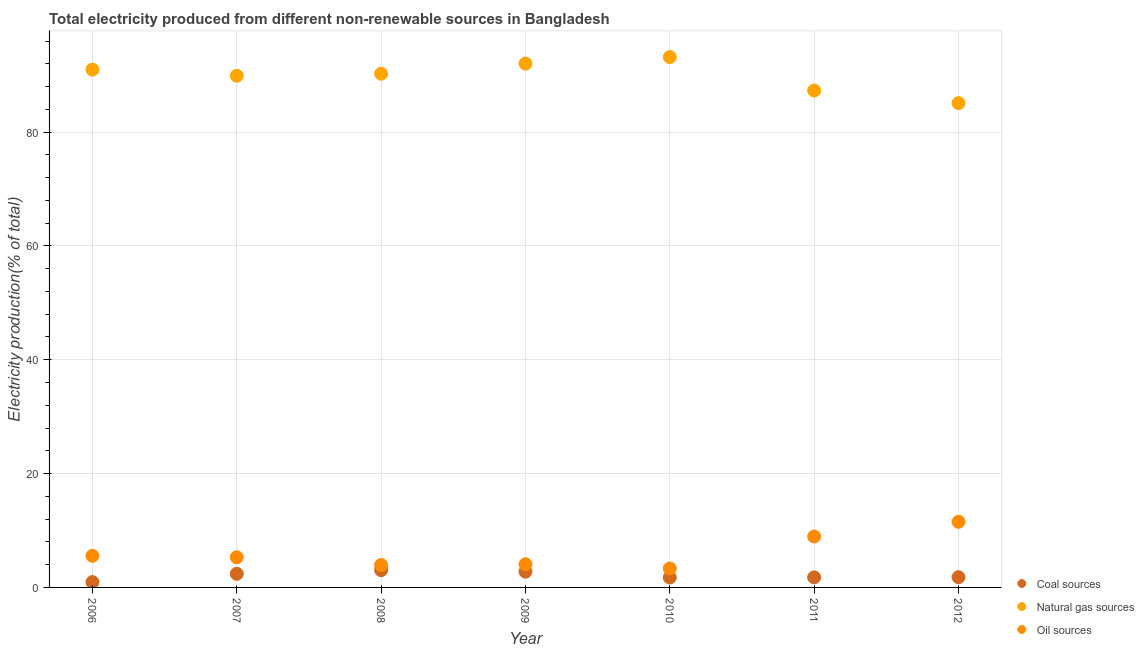What is the percentage of electricity produced by coal in 2007?
Give a very brief answer. 2.39. Across all years, what is the maximum percentage of electricity produced by natural gas?
Keep it short and to the point. 93.18. Across all years, what is the minimum percentage of electricity produced by natural gas?
Your answer should be compact. 85.09. What is the total percentage of electricity produced by oil sources in the graph?
Keep it short and to the point. 42.69. What is the difference between the percentage of electricity produced by natural gas in 2006 and that in 2011?
Your answer should be compact. 3.67. What is the difference between the percentage of electricity produced by natural gas in 2008 and the percentage of electricity produced by coal in 2009?
Offer a very short reply. 87.49. What is the average percentage of electricity produced by natural gas per year?
Your answer should be compact. 89.82. In the year 2011, what is the difference between the percentage of electricity produced by oil sources and percentage of electricity produced by natural gas?
Offer a very short reply. -78.35. In how many years, is the percentage of electricity produced by natural gas greater than 32 %?
Keep it short and to the point. 7. What is the ratio of the percentage of electricity produced by coal in 2006 to that in 2008?
Your answer should be compact. 0.31. Is the percentage of electricity produced by coal in 2010 less than that in 2012?
Give a very brief answer. Yes. What is the difference between the highest and the second highest percentage of electricity produced by oil sources?
Provide a succinct answer. 2.57. What is the difference between the highest and the lowest percentage of electricity produced by oil sources?
Provide a succinct answer. 8.19. In how many years, is the percentage of electricity produced by oil sources greater than the average percentage of electricity produced by oil sources taken over all years?
Keep it short and to the point. 2. How many dotlines are there?
Your answer should be compact. 3. What is the difference between two consecutive major ticks on the Y-axis?
Your response must be concise. 20. Does the graph contain grids?
Give a very brief answer. Yes. Where does the legend appear in the graph?
Make the answer very short. Bottom right. How many legend labels are there?
Your answer should be compact. 3. What is the title of the graph?
Offer a very short reply. Total electricity produced from different non-renewable sources in Bangladesh. Does "Spain" appear as one of the legend labels in the graph?
Provide a succinct answer. No. What is the label or title of the X-axis?
Provide a succinct answer. Year. What is the Electricity production(% of total) of Coal sources in 2006?
Provide a succinct answer. 0.93. What is the Electricity production(% of total) of Natural gas sources in 2006?
Provide a short and direct response. 90.98. What is the Electricity production(% of total) in Oil sources in 2006?
Your answer should be very brief. 5.55. What is the Electricity production(% of total) of Coal sources in 2007?
Your answer should be compact. 2.39. What is the Electricity production(% of total) of Natural gas sources in 2007?
Provide a succinct answer. 89.9. What is the Electricity production(% of total) of Oil sources in 2007?
Provide a succinct answer. 5.3. What is the Electricity production(% of total) in Coal sources in 2008?
Your answer should be very brief. 3.02. What is the Electricity production(% of total) of Natural gas sources in 2008?
Your answer should be compact. 90.26. What is the Electricity production(% of total) of Oil sources in 2008?
Your answer should be compact. 3.95. What is the Electricity production(% of total) of Coal sources in 2009?
Your answer should be compact. 2.77. What is the Electricity production(% of total) in Natural gas sources in 2009?
Offer a very short reply. 92.03. What is the Electricity production(% of total) in Oil sources in 2009?
Keep it short and to the point. 4.08. What is the Electricity production(% of total) in Coal sources in 2010?
Your answer should be very brief. 1.74. What is the Electricity production(% of total) of Natural gas sources in 2010?
Your answer should be compact. 93.18. What is the Electricity production(% of total) of Oil sources in 2010?
Provide a short and direct response. 3.33. What is the Electricity production(% of total) in Coal sources in 2011?
Offer a terse response. 1.77. What is the Electricity production(% of total) of Natural gas sources in 2011?
Your answer should be very brief. 87.31. What is the Electricity production(% of total) of Oil sources in 2011?
Make the answer very short. 8.95. What is the Electricity production(% of total) in Coal sources in 2012?
Your answer should be compact. 1.8. What is the Electricity production(% of total) of Natural gas sources in 2012?
Ensure brevity in your answer.  85.09. What is the Electricity production(% of total) of Oil sources in 2012?
Make the answer very short. 11.53. Across all years, what is the maximum Electricity production(% of total) of Coal sources?
Offer a terse response. 3.02. Across all years, what is the maximum Electricity production(% of total) of Natural gas sources?
Give a very brief answer. 93.18. Across all years, what is the maximum Electricity production(% of total) in Oil sources?
Offer a terse response. 11.53. Across all years, what is the minimum Electricity production(% of total) in Coal sources?
Provide a succinct answer. 0.93. Across all years, what is the minimum Electricity production(% of total) in Natural gas sources?
Keep it short and to the point. 85.09. Across all years, what is the minimum Electricity production(% of total) of Oil sources?
Your answer should be very brief. 3.33. What is the total Electricity production(% of total) of Coal sources in the graph?
Make the answer very short. 14.43. What is the total Electricity production(% of total) of Natural gas sources in the graph?
Provide a short and direct response. 628.74. What is the total Electricity production(% of total) in Oil sources in the graph?
Offer a very short reply. 42.69. What is the difference between the Electricity production(% of total) of Coal sources in 2006 and that in 2007?
Make the answer very short. -1.46. What is the difference between the Electricity production(% of total) of Natural gas sources in 2006 and that in 2007?
Your answer should be compact. 1.08. What is the difference between the Electricity production(% of total) of Oil sources in 2006 and that in 2007?
Keep it short and to the point. 0.25. What is the difference between the Electricity production(% of total) in Coal sources in 2006 and that in 2008?
Your response must be concise. -2.09. What is the difference between the Electricity production(% of total) in Natural gas sources in 2006 and that in 2008?
Ensure brevity in your answer.  0.72. What is the difference between the Electricity production(% of total) in Oil sources in 2006 and that in 2008?
Your response must be concise. 1.6. What is the difference between the Electricity production(% of total) in Coal sources in 2006 and that in 2009?
Give a very brief answer. -1.84. What is the difference between the Electricity production(% of total) in Natural gas sources in 2006 and that in 2009?
Provide a succinct answer. -1.06. What is the difference between the Electricity production(% of total) of Oil sources in 2006 and that in 2009?
Offer a terse response. 1.48. What is the difference between the Electricity production(% of total) of Coal sources in 2006 and that in 2010?
Offer a terse response. -0.81. What is the difference between the Electricity production(% of total) of Natural gas sources in 2006 and that in 2010?
Your answer should be compact. -2.2. What is the difference between the Electricity production(% of total) of Oil sources in 2006 and that in 2010?
Your answer should be very brief. 2.22. What is the difference between the Electricity production(% of total) of Coal sources in 2006 and that in 2011?
Offer a very short reply. -0.83. What is the difference between the Electricity production(% of total) in Natural gas sources in 2006 and that in 2011?
Give a very brief answer. 3.67. What is the difference between the Electricity production(% of total) in Oil sources in 2006 and that in 2011?
Provide a short and direct response. -3.4. What is the difference between the Electricity production(% of total) in Coal sources in 2006 and that in 2012?
Provide a succinct answer. -0.87. What is the difference between the Electricity production(% of total) of Natural gas sources in 2006 and that in 2012?
Give a very brief answer. 5.89. What is the difference between the Electricity production(% of total) of Oil sources in 2006 and that in 2012?
Make the answer very short. -5.97. What is the difference between the Electricity production(% of total) of Coal sources in 2007 and that in 2008?
Provide a short and direct response. -0.64. What is the difference between the Electricity production(% of total) in Natural gas sources in 2007 and that in 2008?
Offer a very short reply. -0.36. What is the difference between the Electricity production(% of total) in Oil sources in 2007 and that in 2008?
Give a very brief answer. 1.35. What is the difference between the Electricity production(% of total) in Coal sources in 2007 and that in 2009?
Keep it short and to the point. -0.38. What is the difference between the Electricity production(% of total) of Natural gas sources in 2007 and that in 2009?
Provide a short and direct response. -2.14. What is the difference between the Electricity production(% of total) of Oil sources in 2007 and that in 2009?
Provide a succinct answer. 1.22. What is the difference between the Electricity production(% of total) of Coal sources in 2007 and that in 2010?
Your response must be concise. 0.65. What is the difference between the Electricity production(% of total) in Natural gas sources in 2007 and that in 2010?
Keep it short and to the point. -3.28. What is the difference between the Electricity production(% of total) of Oil sources in 2007 and that in 2010?
Provide a short and direct response. 1.96. What is the difference between the Electricity production(% of total) in Coal sources in 2007 and that in 2011?
Make the answer very short. 0.62. What is the difference between the Electricity production(% of total) of Natural gas sources in 2007 and that in 2011?
Keep it short and to the point. 2.59. What is the difference between the Electricity production(% of total) in Oil sources in 2007 and that in 2011?
Offer a terse response. -3.66. What is the difference between the Electricity production(% of total) of Coal sources in 2007 and that in 2012?
Your response must be concise. 0.59. What is the difference between the Electricity production(% of total) in Natural gas sources in 2007 and that in 2012?
Ensure brevity in your answer.  4.81. What is the difference between the Electricity production(% of total) in Oil sources in 2007 and that in 2012?
Give a very brief answer. -6.23. What is the difference between the Electricity production(% of total) in Coal sources in 2008 and that in 2009?
Your answer should be compact. 0.25. What is the difference between the Electricity production(% of total) of Natural gas sources in 2008 and that in 2009?
Provide a succinct answer. -1.78. What is the difference between the Electricity production(% of total) in Oil sources in 2008 and that in 2009?
Provide a short and direct response. -0.13. What is the difference between the Electricity production(% of total) of Coal sources in 2008 and that in 2010?
Provide a short and direct response. 1.28. What is the difference between the Electricity production(% of total) in Natural gas sources in 2008 and that in 2010?
Offer a terse response. -2.92. What is the difference between the Electricity production(% of total) of Oil sources in 2008 and that in 2010?
Your answer should be very brief. 0.61. What is the difference between the Electricity production(% of total) in Coal sources in 2008 and that in 2011?
Offer a terse response. 1.26. What is the difference between the Electricity production(% of total) of Natural gas sources in 2008 and that in 2011?
Keep it short and to the point. 2.95. What is the difference between the Electricity production(% of total) of Oil sources in 2008 and that in 2011?
Provide a succinct answer. -5. What is the difference between the Electricity production(% of total) in Coal sources in 2008 and that in 2012?
Offer a very short reply. 1.22. What is the difference between the Electricity production(% of total) in Natural gas sources in 2008 and that in 2012?
Your answer should be very brief. 5.17. What is the difference between the Electricity production(% of total) in Oil sources in 2008 and that in 2012?
Provide a short and direct response. -7.58. What is the difference between the Electricity production(% of total) in Coal sources in 2009 and that in 2010?
Ensure brevity in your answer.  1.03. What is the difference between the Electricity production(% of total) of Natural gas sources in 2009 and that in 2010?
Offer a terse response. -1.14. What is the difference between the Electricity production(% of total) in Oil sources in 2009 and that in 2010?
Your response must be concise. 0.74. What is the difference between the Electricity production(% of total) of Natural gas sources in 2009 and that in 2011?
Provide a short and direct response. 4.73. What is the difference between the Electricity production(% of total) in Oil sources in 2009 and that in 2011?
Make the answer very short. -4.88. What is the difference between the Electricity production(% of total) of Coal sources in 2009 and that in 2012?
Provide a short and direct response. 0.97. What is the difference between the Electricity production(% of total) of Natural gas sources in 2009 and that in 2012?
Your answer should be compact. 6.95. What is the difference between the Electricity production(% of total) of Oil sources in 2009 and that in 2012?
Your answer should be compact. -7.45. What is the difference between the Electricity production(% of total) in Coal sources in 2010 and that in 2011?
Your response must be concise. -0.02. What is the difference between the Electricity production(% of total) in Natural gas sources in 2010 and that in 2011?
Your answer should be compact. 5.87. What is the difference between the Electricity production(% of total) in Oil sources in 2010 and that in 2011?
Your answer should be very brief. -5.62. What is the difference between the Electricity production(% of total) of Coal sources in 2010 and that in 2012?
Provide a succinct answer. -0.06. What is the difference between the Electricity production(% of total) of Natural gas sources in 2010 and that in 2012?
Make the answer very short. 8.09. What is the difference between the Electricity production(% of total) of Oil sources in 2010 and that in 2012?
Give a very brief answer. -8.19. What is the difference between the Electricity production(% of total) in Coal sources in 2011 and that in 2012?
Provide a short and direct response. -0.03. What is the difference between the Electricity production(% of total) of Natural gas sources in 2011 and that in 2012?
Give a very brief answer. 2.22. What is the difference between the Electricity production(% of total) of Oil sources in 2011 and that in 2012?
Your answer should be compact. -2.57. What is the difference between the Electricity production(% of total) in Coal sources in 2006 and the Electricity production(% of total) in Natural gas sources in 2007?
Offer a very short reply. -88.96. What is the difference between the Electricity production(% of total) of Coal sources in 2006 and the Electricity production(% of total) of Oil sources in 2007?
Offer a very short reply. -4.36. What is the difference between the Electricity production(% of total) of Natural gas sources in 2006 and the Electricity production(% of total) of Oil sources in 2007?
Offer a very short reply. 85.68. What is the difference between the Electricity production(% of total) of Coal sources in 2006 and the Electricity production(% of total) of Natural gas sources in 2008?
Make the answer very short. -89.32. What is the difference between the Electricity production(% of total) of Coal sources in 2006 and the Electricity production(% of total) of Oil sources in 2008?
Keep it short and to the point. -3.01. What is the difference between the Electricity production(% of total) of Natural gas sources in 2006 and the Electricity production(% of total) of Oil sources in 2008?
Ensure brevity in your answer.  87.03. What is the difference between the Electricity production(% of total) in Coal sources in 2006 and the Electricity production(% of total) in Natural gas sources in 2009?
Provide a short and direct response. -91.1. What is the difference between the Electricity production(% of total) in Coal sources in 2006 and the Electricity production(% of total) in Oil sources in 2009?
Your response must be concise. -3.14. What is the difference between the Electricity production(% of total) in Natural gas sources in 2006 and the Electricity production(% of total) in Oil sources in 2009?
Provide a succinct answer. 86.9. What is the difference between the Electricity production(% of total) of Coal sources in 2006 and the Electricity production(% of total) of Natural gas sources in 2010?
Offer a terse response. -92.24. What is the difference between the Electricity production(% of total) of Coal sources in 2006 and the Electricity production(% of total) of Oil sources in 2010?
Provide a short and direct response. -2.4. What is the difference between the Electricity production(% of total) in Natural gas sources in 2006 and the Electricity production(% of total) in Oil sources in 2010?
Make the answer very short. 87.64. What is the difference between the Electricity production(% of total) of Coal sources in 2006 and the Electricity production(% of total) of Natural gas sources in 2011?
Ensure brevity in your answer.  -86.37. What is the difference between the Electricity production(% of total) in Coal sources in 2006 and the Electricity production(% of total) in Oil sources in 2011?
Offer a very short reply. -8.02. What is the difference between the Electricity production(% of total) in Natural gas sources in 2006 and the Electricity production(% of total) in Oil sources in 2011?
Provide a short and direct response. 82.02. What is the difference between the Electricity production(% of total) in Coal sources in 2006 and the Electricity production(% of total) in Natural gas sources in 2012?
Your response must be concise. -84.16. What is the difference between the Electricity production(% of total) in Coal sources in 2006 and the Electricity production(% of total) in Oil sources in 2012?
Ensure brevity in your answer.  -10.59. What is the difference between the Electricity production(% of total) of Natural gas sources in 2006 and the Electricity production(% of total) of Oil sources in 2012?
Your answer should be very brief. 79.45. What is the difference between the Electricity production(% of total) in Coal sources in 2007 and the Electricity production(% of total) in Natural gas sources in 2008?
Offer a terse response. -87.87. What is the difference between the Electricity production(% of total) in Coal sources in 2007 and the Electricity production(% of total) in Oil sources in 2008?
Offer a very short reply. -1.56. What is the difference between the Electricity production(% of total) of Natural gas sources in 2007 and the Electricity production(% of total) of Oil sources in 2008?
Your answer should be very brief. 85.95. What is the difference between the Electricity production(% of total) of Coal sources in 2007 and the Electricity production(% of total) of Natural gas sources in 2009?
Provide a short and direct response. -89.65. What is the difference between the Electricity production(% of total) of Coal sources in 2007 and the Electricity production(% of total) of Oil sources in 2009?
Offer a very short reply. -1.69. What is the difference between the Electricity production(% of total) in Natural gas sources in 2007 and the Electricity production(% of total) in Oil sources in 2009?
Give a very brief answer. 85.82. What is the difference between the Electricity production(% of total) in Coal sources in 2007 and the Electricity production(% of total) in Natural gas sources in 2010?
Your answer should be compact. -90.79. What is the difference between the Electricity production(% of total) in Coal sources in 2007 and the Electricity production(% of total) in Oil sources in 2010?
Offer a terse response. -0.94. What is the difference between the Electricity production(% of total) in Natural gas sources in 2007 and the Electricity production(% of total) in Oil sources in 2010?
Your answer should be compact. 86.56. What is the difference between the Electricity production(% of total) in Coal sources in 2007 and the Electricity production(% of total) in Natural gas sources in 2011?
Offer a very short reply. -84.92. What is the difference between the Electricity production(% of total) of Coal sources in 2007 and the Electricity production(% of total) of Oil sources in 2011?
Provide a short and direct response. -6.56. What is the difference between the Electricity production(% of total) in Natural gas sources in 2007 and the Electricity production(% of total) in Oil sources in 2011?
Keep it short and to the point. 80.94. What is the difference between the Electricity production(% of total) in Coal sources in 2007 and the Electricity production(% of total) in Natural gas sources in 2012?
Your answer should be compact. -82.7. What is the difference between the Electricity production(% of total) in Coal sources in 2007 and the Electricity production(% of total) in Oil sources in 2012?
Ensure brevity in your answer.  -9.14. What is the difference between the Electricity production(% of total) of Natural gas sources in 2007 and the Electricity production(% of total) of Oil sources in 2012?
Give a very brief answer. 78.37. What is the difference between the Electricity production(% of total) in Coal sources in 2008 and the Electricity production(% of total) in Natural gas sources in 2009?
Provide a short and direct response. -89.01. What is the difference between the Electricity production(% of total) in Coal sources in 2008 and the Electricity production(% of total) in Oil sources in 2009?
Make the answer very short. -1.05. What is the difference between the Electricity production(% of total) of Natural gas sources in 2008 and the Electricity production(% of total) of Oil sources in 2009?
Give a very brief answer. 86.18. What is the difference between the Electricity production(% of total) of Coal sources in 2008 and the Electricity production(% of total) of Natural gas sources in 2010?
Make the answer very short. -90.15. What is the difference between the Electricity production(% of total) of Coal sources in 2008 and the Electricity production(% of total) of Oil sources in 2010?
Your answer should be very brief. -0.31. What is the difference between the Electricity production(% of total) in Natural gas sources in 2008 and the Electricity production(% of total) in Oil sources in 2010?
Provide a succinct answer. 86.93. What is the difference between the Electricity production(% of total) of Coal sources in 2008 and the Electricity production(% of total) of Natural gas sources in 2011?
Your response must be concise. -84.28. What is the difference between the Electricity production(% of total) in Coal sources in 2008 and the Electricity production(% of total) in Oil sources in 2011?
Keep it short and to the point. -5.93. What is the difference between the Electricity production(% of total) in Natural gas sources in 2008 and the Electricity production(% of total) in Oil sources in 2011?
Provide a short and direct response. 81.31. What is the difference between the Electricity production(% of total) in Coal sources in 2008 and the Electricity production(% of total) in Natural gas sources in 2012?
Your response must be concise. -82.06. What is the difference between the Electricity production(% of total) of Coal sources in 2008 and the Electricity production(% of total) of Oil sources in 2012?
Keep it short and to the point. -8.5. What is the difference between the Electricity production(% of total) of Natural gas sources in 2008 and the Electricity production(% of total) of Oil sources in 2012?
Your answer should be very brief. 78.73. What is the difference between the Electricity production(% of total) in Coal sources in 2009 and the Electricity production(% of total) in Natural gas sources in 2010?
Make the answer very short. -90.41. What is the difference between the Electricity production(% of total) of Coal sources in 2009 and the Electricity production(% of total) of Oil sources in 2010?
Give a very brief answer. -0.56. What is the difference between the Electricity production(% of total) in Natural gas sources in 2009 and the Electricity production(% of total) in Oil sources in 2010?
Keep it short and to the point. 88.7. What is the difference between the Electricity production(% of total) of Coal sources in 2009 and the Electricity production(% of total) of Natural gas sources in 2011?
Provide a short and direct response. -84.54. What is the difference between the Electricity production(% of total) of Coal sources in 2009 and the Electricity production(% of total) of Oil sources in 2011?
Provide a succinct answer. -6.18. What is the difference between the Electricity production(% of total) in Natural gas sources in 2009 and the Electricity production(% of total) in Oil sources in 2011?
Keep it short and to the point. 83.08. What is the difference between the Electricity production(% of total) in Coal sources in 2009 and the Electricity production(% of total) in Natural gas sources in 2012?
Give a very brief answer. -82.32. What is the difference between the Electricity production(% of total) of Coal sources in 2009 and the Electricity production(% of total) of Oil sources in 2012?
Offer a terse response. -8.76. What is the difference between the Electricity production(% of total) of Natural gas sources in 2009 and the Electricity production(% of total) of Oil sources in 2012?
Provide a short and direct response. 80.51. What is the difference between the Electricity production(% of total) of Coal sources in 2010 and the Electricity production(% of total) of Natural gas sources in 2011?
Provide a short and direct response. -85.56. What is the difference between the Electricity production(% of total) in Coal sources in 2010 and the Electricity production(% of total) in Oil sources in 2011?
Make the answer very short. -7.21. What is the difference between the Electricity production(% of total) of Natural gas sources in 2010 and the Electricity production(% of total) of Oil sources in 2011?
Give a very brief answer. 84.23. What is the difference between the Electricity production(% of total) in Coal sources in 2010 and the Electricity production(% of total) in Natural gas sources in 2012?
Give a very brief answer. -83.35. What is the difference between the Electricity production(% of total) of Coal sources in 2010 and the Electricity production(% of total) of Oil sources in 2012?
Provide a succinct answer. -9.78. What is the difference between the Electricity production(% of total) of Natural gas sources in 2010 and the Electricity production(% of total) of Oil sources in 2012?
Give a very brief answer. 81.65. What is the difference between the Electricity production(% of total) in Coal sources in 2011 and the Electricity production(% of total) in Natural gas sources in 2012?
Keep it short and to the point. -83.32. What is the difference between the Electricity production(% of total) of Coal sources in 2011 and the Electricity production(% of total) of Oil sources in 2012?
Ensure brevity in your answer.  -9.76. What is the difference between the Electricity production(% of total) of Natural gas sources in 2011 and the Electricity production(% of total) of Oil sources in 2012?
Ensure brevity in your answer.  75.78. What is the average Electricity production(% of total) in Coal sources per year?
Keep it short and to the point. 2.06. What is the average Electricity production(% of total) of Natural gas sources per year?
Make the answer very short. 89.82. What is the average Electricity production(% of total) in Oil sources per year?
Your answer should be compact. 6.1. In the year 2006, what is the difference between the Electricity production(% of total) in Coal sources and Electricity production(% of total) in Natural gas sources?
Offer a terse response. -90.04. In the year 2006, what is the difference between the Electricity production(% of total) of Coal sources and Electricity production(% of total) of Oil sources?
Provide a short and direct response. -4.62. In the year 2006, what is the difference between the Electricity production(% of total) of Natural gas sources and Electricity production(% of total) of Oil sources?
Offer a very short reply. 85.42. In the year 2007, what is the difference between the Electricity production(% of total) in Coal sources and Electricity production(% of total) in Natural gas sources?
Provide a short and direct response. -87.51. In the year 2007, what is the difference between the Electricity production(% of total) of Coal sources and Electricity production(% of total) of Oil sources?
Keep it short and to the point. -2.91. In the year 2007, what is the difference between the Electricity production(% of total) in Natural gas sources and Electricity production(% of total) in Oil sources?
Ensure brevity in your answer.  84.6. In the year 2008, what is the difference between the Electricity production(% of total) of Coal sources and Electricity production(% of total) of Natural gas sources?
Your response must be concise. -87.23. In the year 2008, what is the difference between the Electricity production(% of total) of Coal sources and Electricity production(% of total) of Oil sources?
Provide a succinct answer. -0.92. In the year 2008, what is the difference between the Electricity production(% of total) in Natural gas sources and Electricity production(% of total) in Oil sources?
Provide a short and direct response. 86.31. In the year 2009, what is the difference between the Electricity production(% of total) in Coal sources and Electricity production(% of total) in Natural gas sources?
Provide a succinct answer. -89.27. In the year 2009, what is the difference between the Electricity production(% of total) of Coal sources and Electricity production(% of total) of Oil sources?
Ensure brevity in your answer.  -1.31. In the year 2009, what is the difference between the Electricity production(% of total) of Natural gas sources and Electricity production(% of total) of Oil sources?
Offer a very short reply. 87.96. In the year 2010, what is the difference between the Electricity production(% of total) of Coal sources and Electricity production(% of total) of Natural gas sources?
Ensure brevity in your answer.  -91.44. In the year 2010, what is the difference between the Electricity production(% of total) of Coal sources and Electricity production(% of total) of Oil sources?
Keep it short and to the point. -1.59. In the year 2010, what is the difference between the Electricity production(% of total) in Natural gas sources and Electricity production(% of total) in Oil sources?
Offer a very short reply. 89.85. In the year 2011, what is the difference between the Electricity production(% of total) of Coal sources and Electricity production(% of total) of Natural gas sources?
Provide a succinct answer. -85.54. In the year 2011, what is the difference between the Electricity production(% of total) in Coal sources and Electricity production(% of total) in Oil sources?
Ensure brevity in your answer.  -7.19. In the year 2011, what is the difference between the Electricity production(% of total) of Natural gas sources and Electricity production(% of total) of Oil sources?
Offer a very short reply. 78.35. In the year 2012, what is the difference between the Electricity production(% of total) in Coal sources and Electricity production(% of total) in Natural gas sources?
Your answer should be compact. -83.29. In the year 2012, what is the difference between the Electricity production(% of total) in Coal sources and Electricity production(% of total) in Oil sources?
Your answer should be compact. -9.72. In the year 2012, what is the difference between the Electricity production(% of total) in Natural gas sources and Electricity production(% of total) in Oil sources?
Your answer should be compact. 73.56. What is the ratio of the Electricity production(% of total) in Coal sources in 2006 to that in 2007?
Ensure brevity in your answer.  0.39. What is the ratio of the Electricity production(% of total) of Oil sources in 2006 to that in 2007?
Keep it short and to the point. 1.05. What is the ratio of the Electricity production(% of total) in Coal sources in 2006 to that in 2008?
Provide a succinct answer. 0.31. What is the ratio of the Electricity production(% of total) of Oil sources in 2006 to that in 2008?
Offer a very short reply. 1.41. What is the ratio of the Electricity production(% of total) in Coal sources in 2006 to that in 2009?
Make the answer very short. 0.34. What is the ratio of the Electricity production(% of total) in Natural gas sources in 2006 to that in 2009?
Offer a very short reply. 0.99. What is the ratio of the Electricity production(% of total) of Oil sources in 2006 to that in 2009?
Give a very brief answer. 1.36. What is the ratio of the Electricity production(% of total) of Coal sources in 2006 to that in 2010?
Ensure brevity in your answer.  0.54. What is the ratio of the Electricity production(% of total) in Natural gas sources in 2006 to that in 2010?
Keep it short and to the point. 0.98. What is the ratio of the Electricity production(% of total) in Oil sources in 2006 to that in 2010?
Your answer should be compact. 1.67. What is the ratio of the Electricity production(% of total) of Coal sources in 2006 to that in 2011?
Give a very brief answer. 0.53. What is the ratio of the Electricity production(% of total) in Natural gas sources in 2006 to that in 2011?
Make the answer very short. 1.04. What is the ratio of the Electricity production(% of total) in Oil sources in 2006 to that in 2011?
Provide a succinct answer. 0.62. What is the ratio of the Electricity production(% of total) of Coal sources in 2006 to that in 2012?
Offer a terse response. 0.52. What is the ratio of the Electricity production(% of total) of Natural gas sources in 2006 to that in 2012?
Provide a succinct answer. 1.07. What is the ratio of the Electricity production(% of total) in Oil sources in 2006 to that in 2012?
Ensure brevity in your answer.  0.48. What is the ratio of the Electricity production(% of total) in Coal sources in 2007 to that in 2008?
Give a very brief answer. 0.79. What is the ratio of the Electricity production(% of total) in Natural gas sources in 2007 to that in 2008?
Give a very brief answer. 1. What is the ratio of the Electricity production(% of total) in Oil sources in 2007 to that in 2008?
Provide a short and direct response. 1.34. What is the ratio of the Electricity production(% of total) of Coal sources in 2007 to that in 2009?
Offer a terse response. 0.86. What is the ratio of the Electricity production(% of total) in Natural gas sources in 2007 to that in 2009?
Keep it short and to the point. 0.98. What is the ratio of the Electricity production(% of total) of Oil sources in 2007 to that in 2009?
Your response must be concise. 1.3. What is the ratio of the Electricity production(% of total) of Coal sources in 2007 to that in 2010?
Your response must be concise. 1.37. What is the ratio of the Electricity production(% of total) of Natural gas sources in 2007 to that in 2010?
Give a very brief answer. 0.96. What is the ratio of the Electricity production(% of total) of Oil sources in 2007 to that in 2010?
Your response must be concise. 1.59. What is the ratio of the Electricity production(% of total) in Coal sources in 2007 to that in 2011?
Make the answer very short. 1.35. What is the ratio of the Electricity production(% of total) of Natural gas sources in 2007 to that in 2011?
Provide a succinct answer. 1.03. What is the ratio of the Electricity production(% of total) of Oil sources in 2007 to that in 2011?
Provide a succinct answer. 0.59. What is the ratio of the Electricity production(% of total) of Coal sources in 2007 to that in 2012?
Your response must be concise. 1.33. What is the ratio of the Electricity production(% of total) in Natural gas sources in 2007 to that in 2012?
Give a very brief answer. 1.06. What is the ratio of the Electricity production(% of total) in Oil sources in 2007 to that in 2012?
Provide a short and direct response. 0.46. What is the ratio of the Electricity production(% of total) in Coal sources in 2008 to that in 2009?
Keep it short and to the point. 1.09. What is the ratio of the Electricity production(% of total) of Natural gas sources in 2008 to that in 2009?
Your answer should be very brief. 0.98. What is the ratio of the Electricity production(% of total) in Oil sources in 2008 to that in 2009?
Give a very brief answer. 0.97. What is the ratio of the Electricity production(% of total) of Coal sources in 2008 to that in 2010?
Provide a short and direct response. 1.73. What is the ratio of the Electricity production(% of total) of Natural gas sources in 2008 to that in 2010?
Make the answer very short. 0.97. What is the ratio of the Electricity production(% of total) in Oil sources in 2008 to that in 2010?
Your answer should be compact. 1.18. What is the ratio of the Electricity production(% of total) of Coal sources in 2008 to that in 2011?
Ensure brevity in your answer.  1.71. What is the ratio of the Electricity production(% of total) in Natural gas sources in 2008 to that in 2011?
Provide a succinct answer. 1.03. What is the ratio of the Electricity production(% of total) of Oil sources in 2008 to that in 2011?
Offer a very short reply. 0.44. What is the ratio of the Electricity production(% of total) of Coal sources in 2008 to that in 2012?
Offer a terse response. 1.68. What is the ratio of the Electricity production(% of total) of Natural gas sources in 2008 to that in 2012?
Provide a succinct answer. 1.06. What is the ratio of the Electricity production(% of total) in Oil sources in 2008 to that in 2012?
Give a very brief answer. 0.34. What is the ratio of the Electricity production(% of total) of Coal sources in 2009 to that in 2010?
Ensure brevity in your answer.  1.59. What is the ratio of the Electricity production(% of total) in Natural gas sources in 2009 to that in 2010?
Offer a very short reply. 0.99. What is the ratio of the Electricity production(% of total) of Oil sources in 2009 to that in 2010?
Your answer should be very brief. 1.22. What is the ratio of the Electricity production(% of total) of Coal sources in 2009 to that in 2011?
Keep it short and to the point. 1.57. What is the ratio of the Electricity production(% of total) of Natural gas sources in 2009 to that in 2011?
Make the answer very short. 1.05. What is the ratio of the Electricity production(% of total) of Oil sources in 2009 to that in 2011?
Make the answer very short. 0.46. What is the ratio of the Electricity production(% of total) in Coal sources in 2009 to that in 2012?
Your answer should be very brief. 1.54. What is the ratio of the Electricity production(% of total) of Natural gas sources in 2009 to that in 2012?
Your answer should be compact. 1.08. What is the ratio of the Electricity production(% of total) in Oil sources in 2009 to that in 2012?
Ensure brevity in your answer.  0.35. What is the ratio of the Electricity production(% of total) of Coal sources in 2010 to that in 2011?
Ensure brevity in your answer.  0.99. What is the ratio of the Electricity production(% of total) of Natural gas sources in 2010 to that in 2011?
Offer a very short reply. 1.07. What is the ratio of the Electricity production(% of total) of Oil sources in 2010 to that in 2011?
Your answer should be very brief. 0.37. What is the ratio of the Electricity production(% of total) of Coal sources in 2010 to that in 2012?
Make the answer very short. 0.97. What is the ratio of the Electricity production(% of total) of Natural gas sources in 2010 to that in 2012?
Provide a short and direct response. 1.1. What is the ratio of the Electricity production(% of total) of Oil sources in 2010 to that in 2012?
Offer a terse response. 0.29. What is the ratio of the Electricity production(% of total) in Coal sources in 2011 to that in 2012?
Provide a succinct answer. 0.98. What is the ratio of the Electricity production(% of total) in Natural gas sources in 2011 to that in 2012?
Keep it short and to the point. 1.03. What is the ratio of the Electricity production(% of total) in Oil sources in 2011 to that in 2012?
Your answer should be very brief. 0.78. What is the difference between the highest and the second highest Electricity production(% of total) in Coal sources?
Your response must be concise. 0.25. What is the difference between the highest and the second highest Electricity production(% of total) in Natural gas sources?
Give a very brief answer. 1.14. What is the difference between the highest and the second highest Electricity production(% of total) of Oil sources?
Your answer should be compact. 2.57. What is the difference between the highest and the lowest Electricity production(% of total) in Coal sources?
Offer a very short reply. 2.09. What is the difference between the highest and the lowest Electricity production(% of total) of Natural gas sources?
Keep it short and to the point. 8.09. What is the difference between the highest and the lowest Electricity production(% of total) of Oil sources?
Provide a short and direct response. 8.19. 